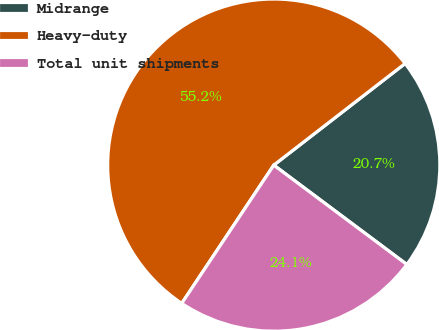Convert chart. <chart><loc_0><loc_0><loc_500><loc_500><pie_chart><fcel>Midrange<fcel>Heavy-duty<fcel>Total unit shipments<nl><fcel>20.69%<fcel>55.17%<fcel>24.14%<nl></chart> 